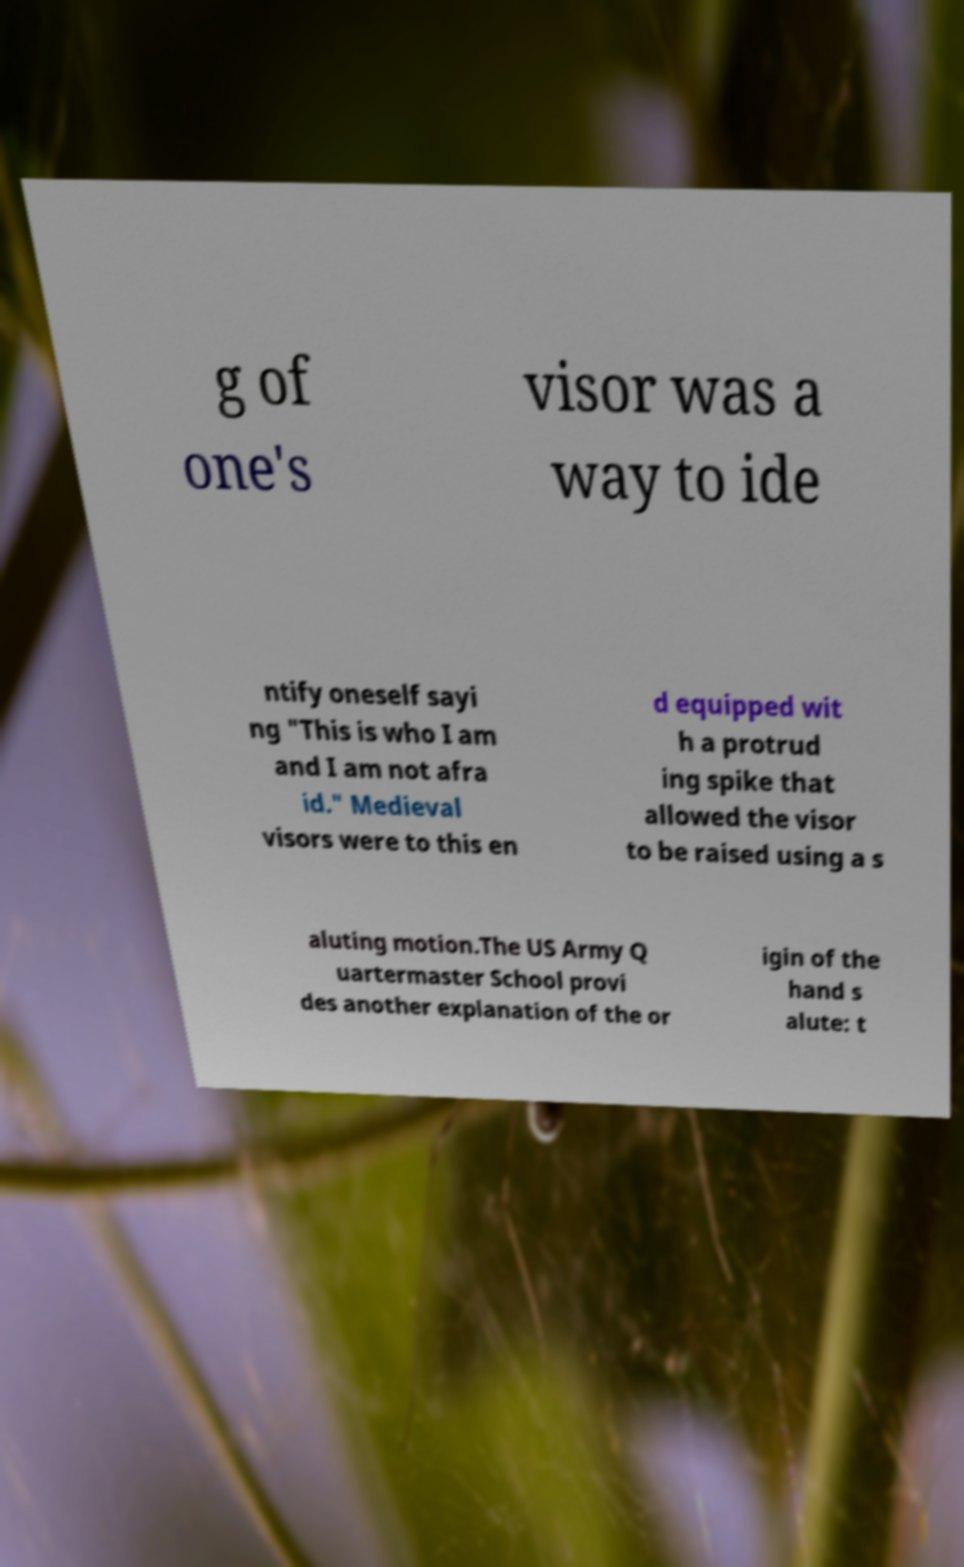Can you accurately transcribe the text from the provided image for me? g of one's visor was a way to ide ntify oneself sayi ng "This is who I am and I am not afra id." Medieval visors were to this en d equipped wit h a protrud ing spike that allowed the visor to be raised using a s aluting motion.The US Army Q uartermaster School provi des another explanation of the or igin of the hand s alute: t 